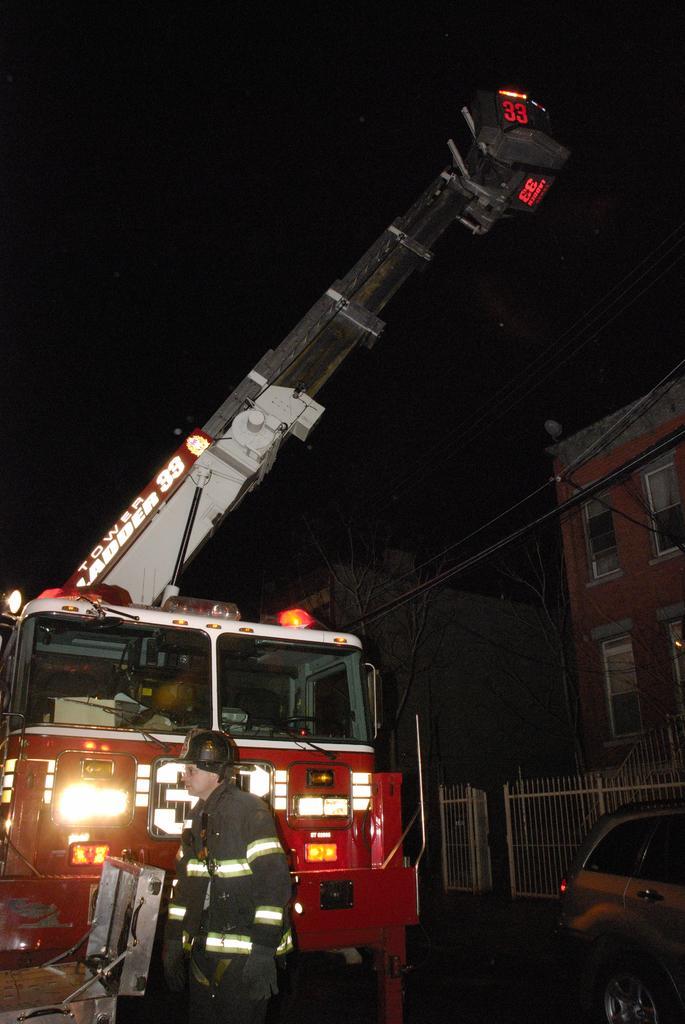How would you summarize this image in a sentence or two? In this image we can see a person standing and behind we can see the fire engine and on the right side we can see a car. In the background, we can see two buildings and some trees. 